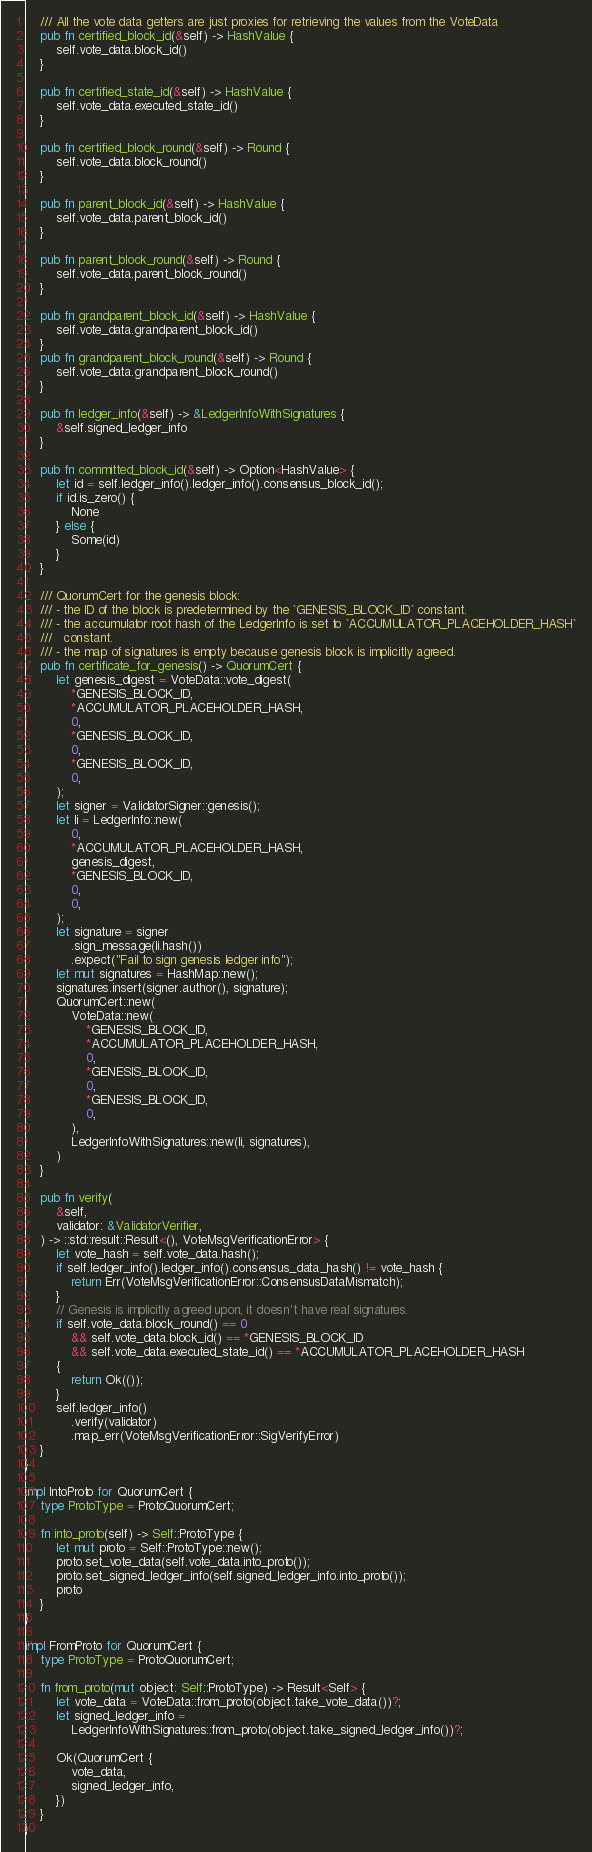<code> <loc_0><loc_0><loc_500><loc_500><_Rust_>    /// All the vote data getters are just proxies for retrieving the values from the VoteData
    pub fn certified_block_id(&self) -> HashValue {
        self.vote_data.block_id()
    }

    pub fn certified_state_id(&self) -> HashValue {
        self.vote_data.executed_state_id()
    }

    pub fn certified_block_round(&self) -> Round {
        self.vote_data.block_round()
    }

    pub fn parent_block_id(&self) -> HashValue {
        self.vote_data.parent_block_id()
    }

    pub fn parent_block_round(&self) -> Round {
        self.vote_data.parent_block_round()
    }

    pub fn grandparent_block_id(&self) -> HashValue {
        self.vote_data.grandparent_block_id()
    }
    pub fn grandparent_block_round(&self) -> Round {
        self.vote_data.grandparent_block_round()
    }

    pub fn ledger_info(&self) -> &LedgerInfoWithSignatures {
        &self.signed_ledger_info
    }

    pub fn committed_block_id(&self) -> Option<HashValue> {
        let id = self.ledger_info().ledger_info().consensus_block_id();
        if id.is_zero() {
            None
        } else {
            Some(id)
        }
    }

    /// QuorumCert for the genesis block:
    /// - the ID of the block is predetermined by the `GENESIS_BLOCK_ID` constant.
    /// - the accumulator root hash of the LedgerInfo is set to `ACCUMULATOR_PLACEHOLDER_HASH`
    ///   constant.
    /// - the map of signatures is empty because genesis block is implicitly agreed.
    pub fn certificate_for_genesis() -> QuorumCert {
        let genesis_digest = VoteData::vote_digest(
            *GENESIS_BLOCK_ID,
            *ACCUMULATOR_PLACEHOLDER_HASH,
            0,
            *GENESIS_BLOCK_ID,
            0,
            *GENESIS_BLOCK_ID,
            0,
        );
        let signer = ValidatorSigner::genesis();
        let li = LedgerInfo::new(
            0,
            *ACCUMULATOR_PLACEHOLDER_HASH,
            genesis_digest,
            *GENESIS_BLOCK_ID,
            0,
            0,
        );
        let signature = signer
            .sign_message(li.hash())
            .expect("Fail to sign genesis ledger info");
        let mut signatures = HashMap::new();
        signatures.insert(signer.author(), signature);
        QuorumCert::new(
            VoteData::new(
                *GENESIS_BLOCK_ID,
                *ACCUMULATOR_PLACEHOLDER_HASH,
                0,
                *GENESIS_BLOCK_ID,
                0,
                *GENESIS_BLOCK_ID,
                0,
            ),
            LedgerInfoWithSignatures::new(li, signatures),
        )
    }

    pub fn verify(
        &self,
        validator: &ValidatorVerifier,
    ) -> ::std::result::Result<(), VoteMsgVerificationError> {
        let vote_hash = self.vote_data.hash();
        if self.ledger_info().ledger_info().consensus_data_hash() != vote_hash {
            return Err(VoteMsgVerificationError::ConsensusDataMismatch);
        }
        // Genesis is implicitly agreed upon, it doesn't have real signatures.
        if self.vote_data.block_round() == 0
            && self.vote_data.block_id() == *GENESIS_BLOCK_ID
            && self.vote_data.executed_state_id() == *ACCUMULATOR_PLACEHOLDER_HASH
        {
            return Ok(());
        }
        self.ledger_info()
            .verify(validator)
            .map_err(VoteMsgVerificationError::SigVerifyError)
    }
}

impl IntoProto for QuorumCert {
    type ProtoType = ProtoQuorumCert;

    fn into_proto(self) -> Self::ProtoType {
        let mut proto = Self::ProtoType::new();
        proto.set_vote_data(self.vote_data.into_proto());
        proto.set_signed_ledger_info(self.signed_ledger_info.into_proto());
        proto
    }
}

impl FromProto for QuorumCert {
    type ProtoType = ProtoQuorumCert;

    fn from_proto(mut object: Self::ProtoType) -> Result<Self> {
        let vote_data = VoteData::from_proto(object.take_vote_data())?;
        let signed_ledger_info =
            LedgerInfoWithSignatures::from_proto(object.take_signed_ledger_info())?;

        Ok(QuorumCert {
            vote_data,
            signed_ledger_info,
        })
    }
}
</code> 